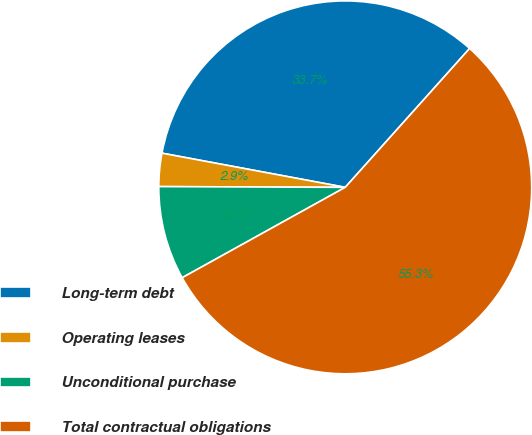Convert chart. <chart><loc_0><loc_0><loc_500><loc_500><pie_chart><fcel>Long-term debt<fcel>Operating leases<fcel>Unconditional purchase<fcel>Total contractual obligations<nl><fcel>33.69%<fcel>2.87%<fcel>8.12%<fcel>55.32%<nl></chart> 